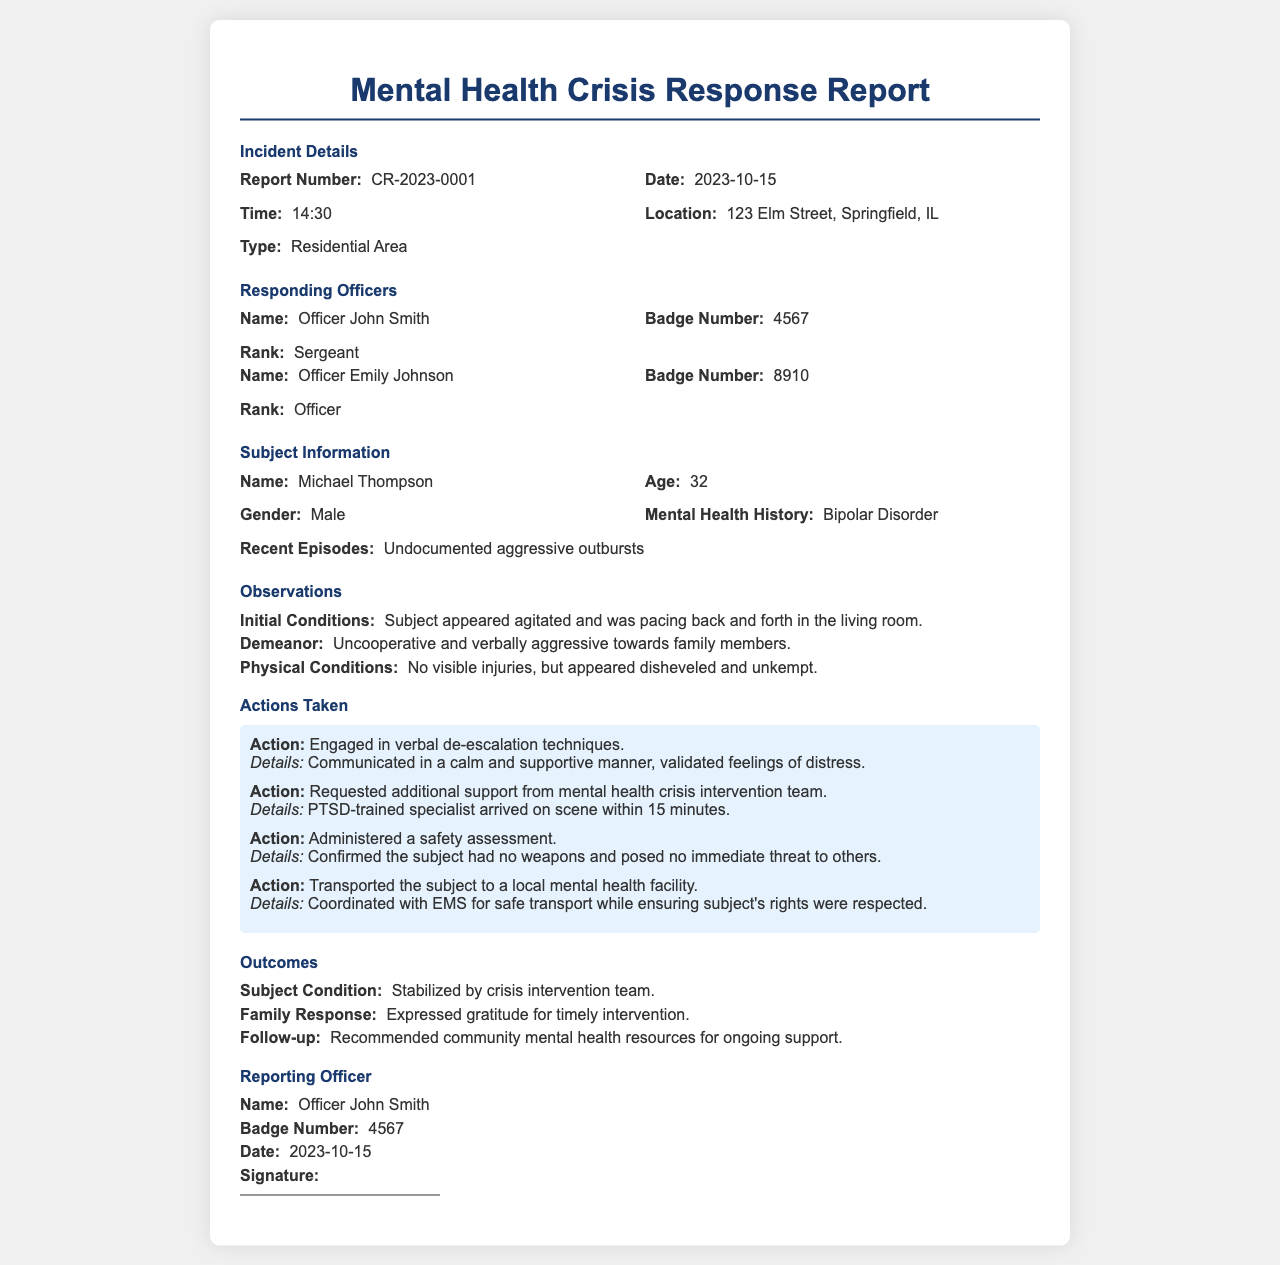What is the report number? The report number is listed in the incident details section as the unique identifier for this report.
Answer: CR-2023-0001 What is the name of the subject? The subject's name is provided in the subject information section.
Answer: Michael Thompson What was the subject's mental health history? The document mentions the subject's mental health history under the subject information section.
Answer: Bipolar Disorder What action was taken to support the subject? The actions taken include engaging in verbal de-escalation techniques as highlighted in the actions section.
Answer: Engaged in verbal de-escalation techniques How long did it take for the mental health crisis intervention team to arrive? This information can be found in the actions taken section detailing the response times.
Answer: 15 minutes What time was the incident reported? The time is specified in the incident details section and indicates when officers responded to the situation.
Answer: 14:30 Who were the responding officers? The names of the responding officers are included in the responding officers section of the report.
Answer: Officer John Smith, Officer Emily Johnson What follow-up action was recommended? The follow-up details mentioned in the outcomes section indicate the next steps for support.
Answer: Recommended community mental health resources for ongoing support What was the subject's demeanor upon arrival? The subject's demeanor is described in the observations section, reflecting their initial behavior.
Answer: Uncooperative and verbally aggressive towards family members 